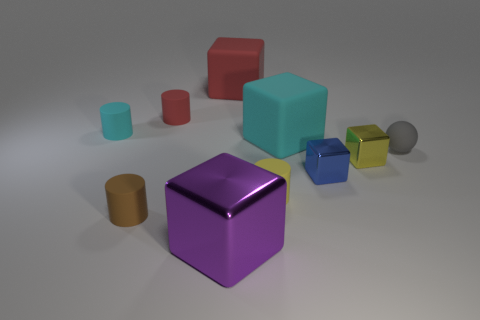Subtract 2 cubes. How many cubes are left? 3 Subtract all blue spheres. Subtract all yellow blocks. How many spheres are left? 1 Subtract all balls. How many objects are left? 9 Subtract all small yellow rubber objects. Subtract all large shiny objects. How many objects are left? 8 Add 2 small things. How many small things are left? 9 Add 5 tiny blue metal spheres. How many tiny blue metal spheres exist? 5 Subtract 1 purple cubes. How many objects are left? 9 